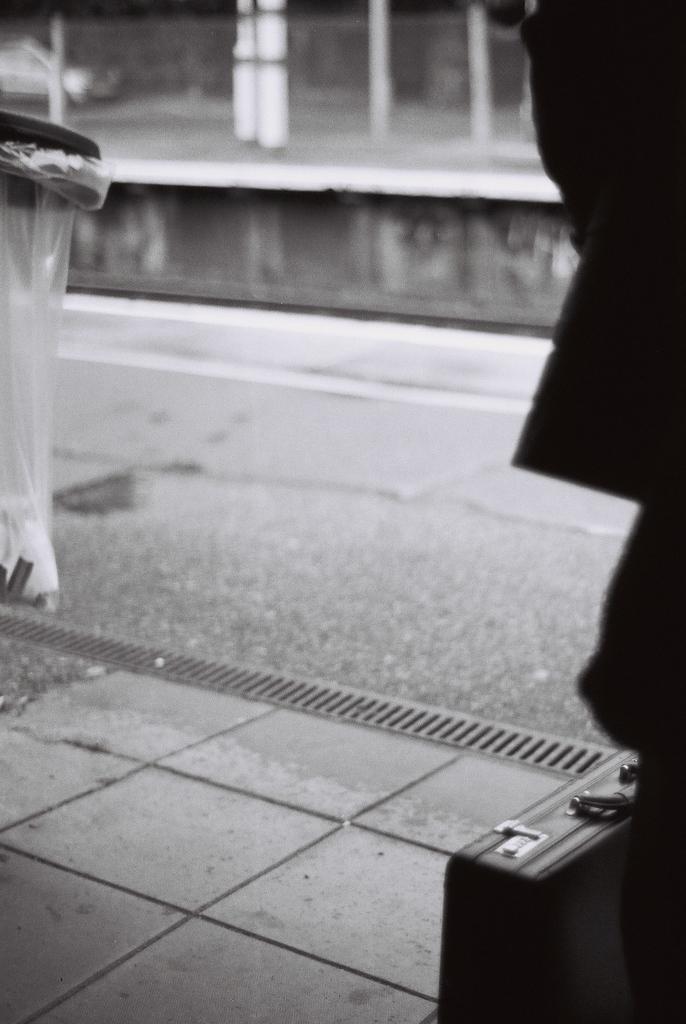Can you describe this image briefly? This is a sidewalk. A suitcase is kept on the sidewalk. There is a drainage grill near the sidewalk. There is a plastic bag. And there is a road. Beside the wall there is a wall. 